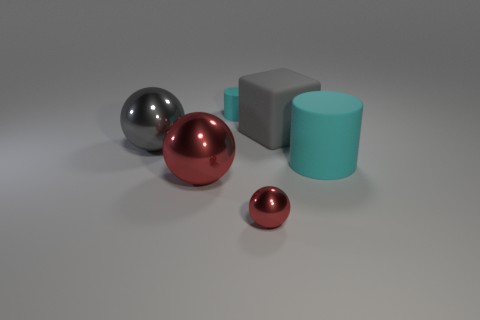Subtract all red balls. How many balls are left? 1 Subtract all gray balls. How many balls are left? 2 Subtract 1 cubes. How many cubes are left? 0 Subtract all cylinders. How many objects are left? 4 Add 4 large green cylinders. How many large green cylinders exist? 4 Add 2 large gray objects. How many objects exist? 8 Subtract 1 cyan cylinders. How many objects are left? 5 Subtract all cyan balls. Subtract all gray blocks. How many balls are left? 3 Subtract all blue cubes. How many gray spheres are left? 1 Subtract all large red matte things. Subtract all tiny red spheres. How many objects are left? 5 